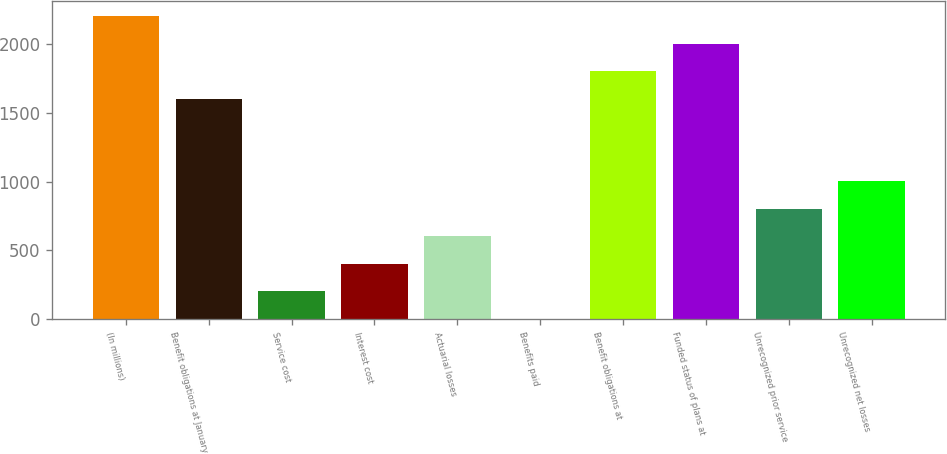Convert chart. <chart><loc_0><loc_0><loc_500><loc_500><bar_chart><fcel>(In millions)<fcel>Benefit obligations at January<fcel>Service cost<fcel>Interest cost<fcel>Actuarial losses<fcel>Benefits paid<fcel>Benefit obligations at<fcel>Funded status of plans at<fcel>Unrecognized prior service<fcel>Unrecognized net losses<nl><fcel>2202.9<fcel>1603.2<fcel>203.9<fcel>403.8<fcel>603.7<fcel>4<fcel>1803.1<fcel>2003<fcel>803.6<fcel>1003.5<nl></chart> 